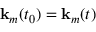Convert formula to latex. <formula><loc_0><loc_0><loc_500><loc_500>k _ { m } ( t _ { 0 } ) = k _ { m } ( t )</formula> 